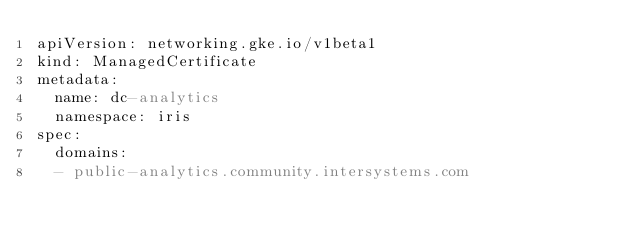Convert code to text. <code><loc_0><loc_0><loc_500><loc_500><_YAML_>apiVersion: networking.gke.io/v1beta1
kind: ManagedCertificate
metadata:
  name: dc-analytics
  namespace: iris
spec:
  domains:
  - public-analytics.community.intersystems.com
</code> 